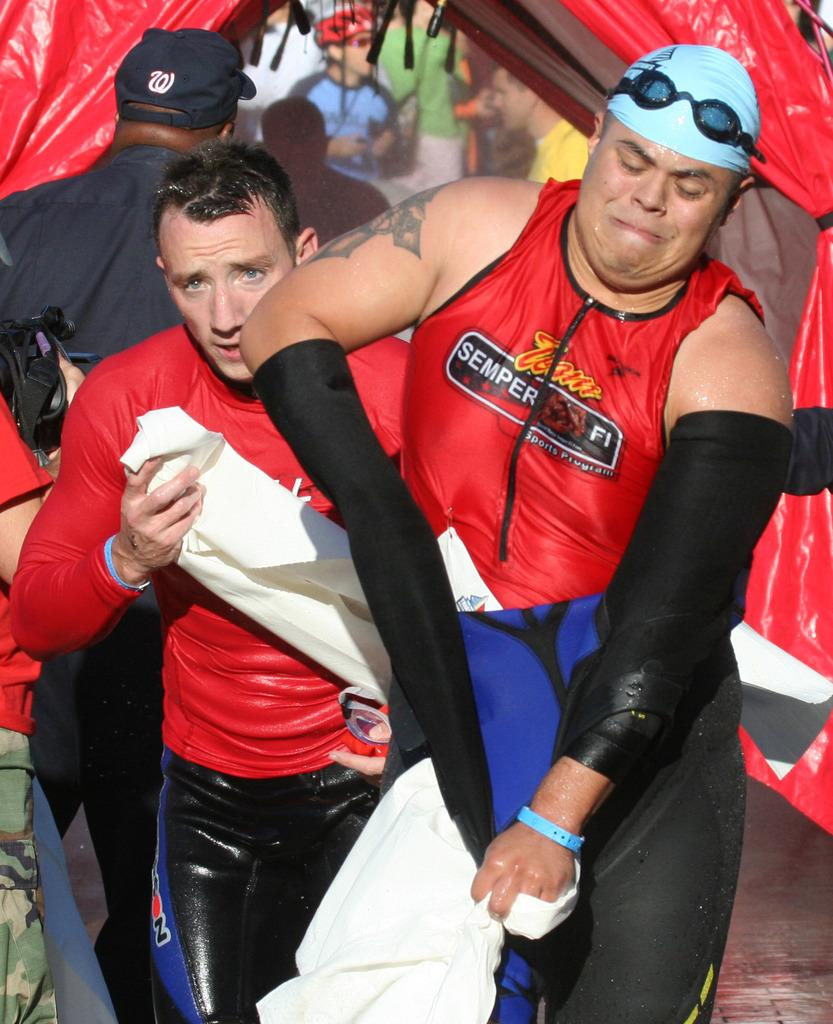Provide a one-sentence caption for the provided image. Team Seper Fi wears a red and black top as they towel off. 